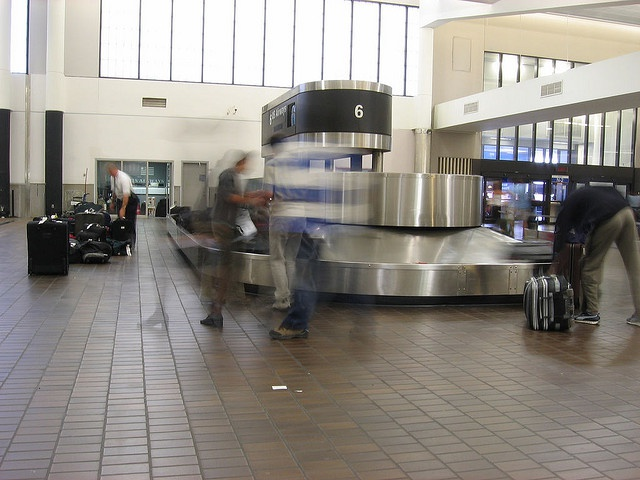Describe the objects in this image and their specific colors. I can see people in lightgray, black, and gray tones, people in lightgray, black, gray, and maroon tones, suitcase in lightgray, black, gray, and darkgray tones, suitcase in lightgray, black, gray, and white tones, and people in lightgray, black, gray, and darkgray tones in this image. 